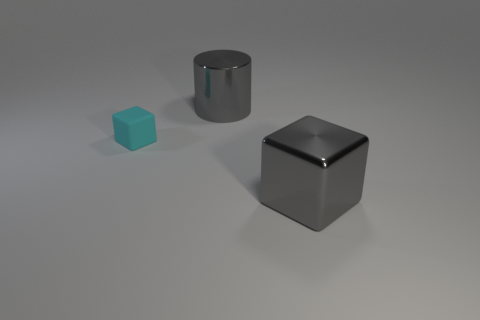What number of other cyan matte cubes are the same size as the cyan rubber cube?
Your response must be concise. 0. Is the number of big rubber balls less than the number of gray blocks?
Make the answer very short. Yes. There is a large gray thing that is to the left of the big gray metallic thing in front of the big gray shiny cylinder; what shape is it?
Provide a short and direct response. Cylinder. What shape is the thing that is the same size as the shiny block?
Make the answer very short. Cylinder. Are there any red metal objects that have the same shape as the cyan matte thing?
Your response must be concise. No. What material is the tiny block?
Provide a succinct answer. Rubber. There is a small cyan rubber cube; are there any large gray metal objects left of it?
Ensure brevity in your answer.  No. There is a cylinder that is right of the small thing; what number of gray metal objects are behind it?
Your answer should be compact. 0. What is the material of the block that is the same size as the gray shiny cylinder?
Provide a short and direct response. Metal. How many other things are there of the same material as the big gray cube?
Provide a succinct answer. 1. 